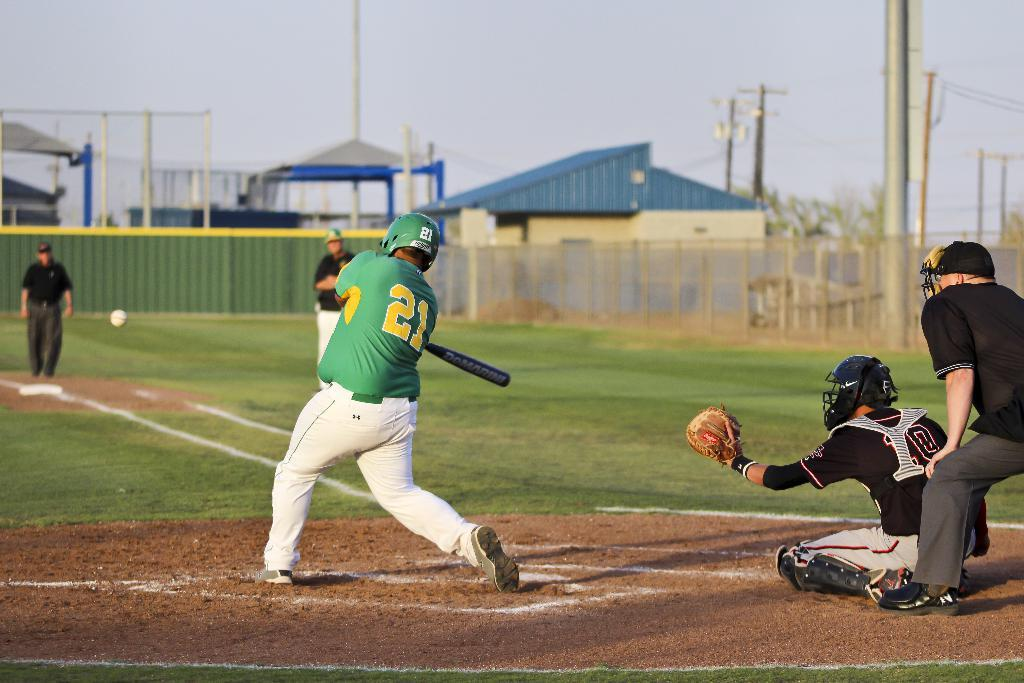Provide a one-sentence caption for the provided image. A baseball player in a green shirt with the number 21 on his back hits a ball. 